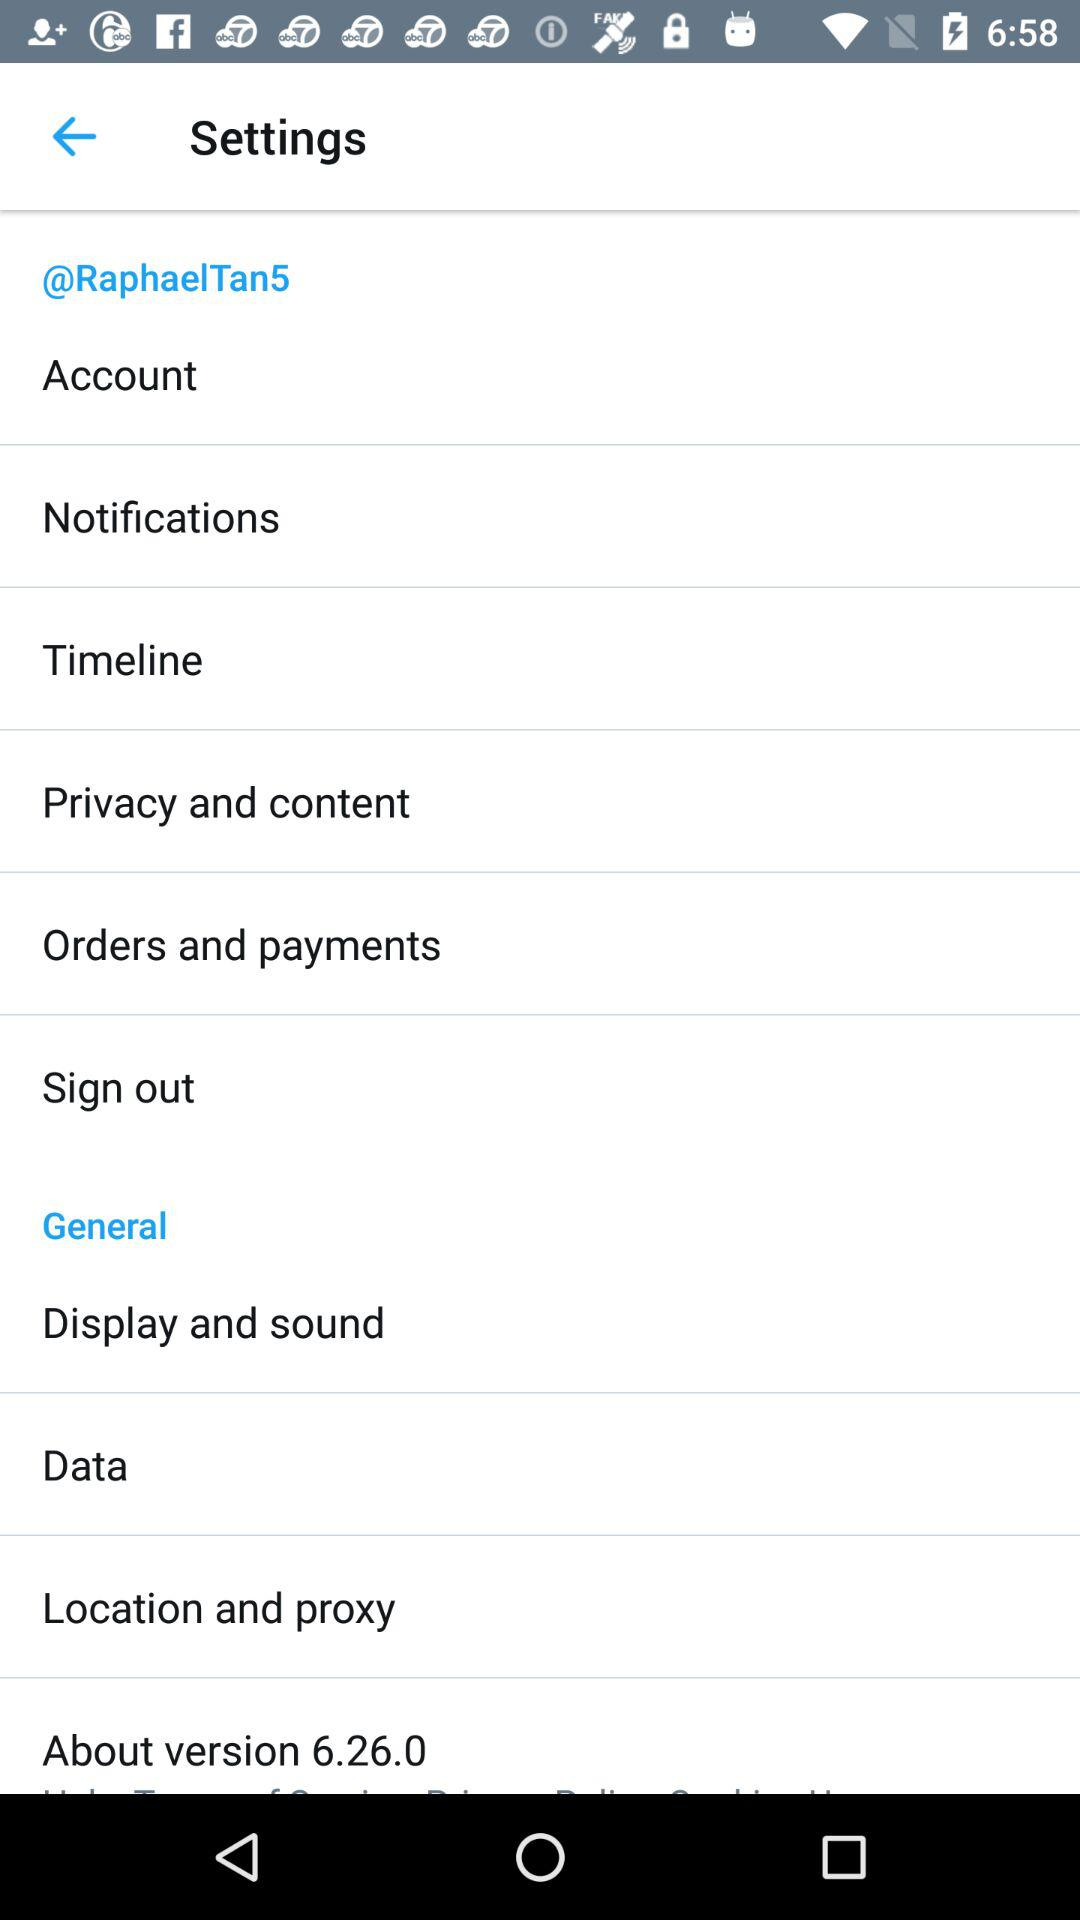What is the username? The username is "@RaphaelTan5". 